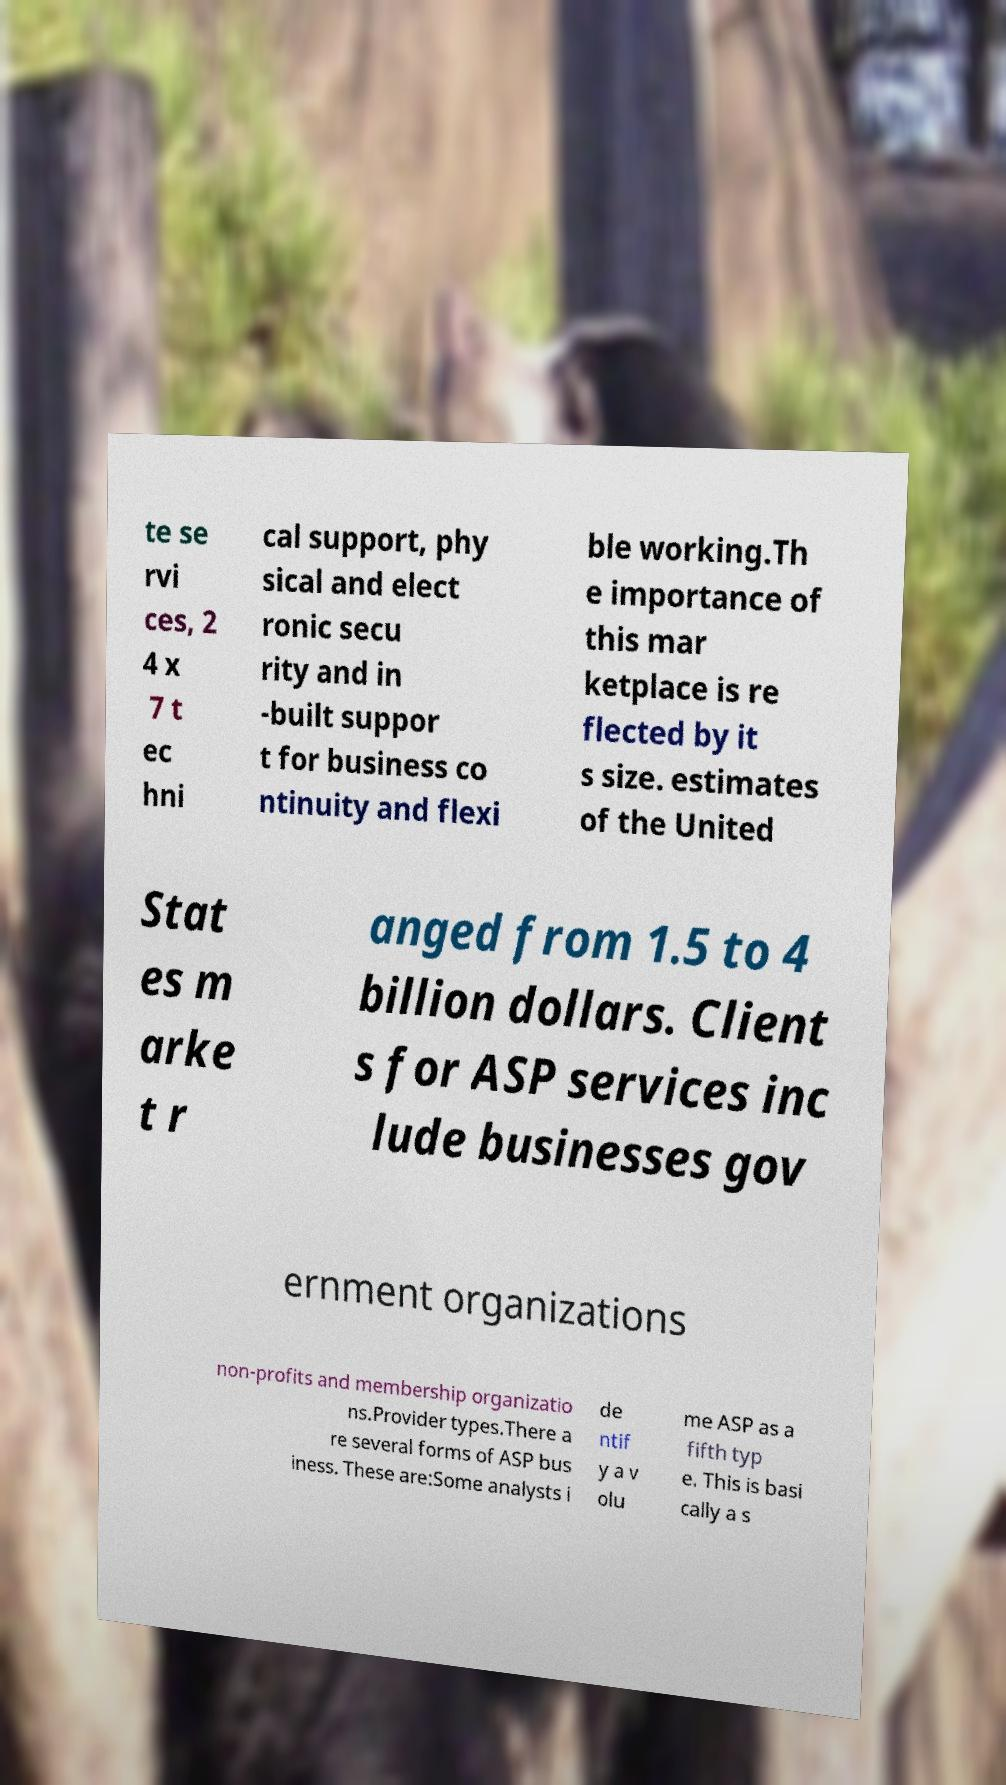What messages or text are displayed in this image? I need them in a readable, typed format. te se rvi ces, 2 4 x 7 t ec hni cal support, phy sical and elect ronic secu rity and in -built suppor t for business co ntinuity and flexi ble working.Th e importance of this mar ketplace is re flected by it s size. estimates of the United Stat es m arke t r anged from 1.5 to 4 billion dollars. Client s for ASP services inc lude businesses gov ernment organizations non-profits and membership organizatio ns.Provider types.There a re several forms of ASP bus iness. These are:Some analysts i de ntif y a v olu me ASP as a fifth typ e. This is basi cally a s 